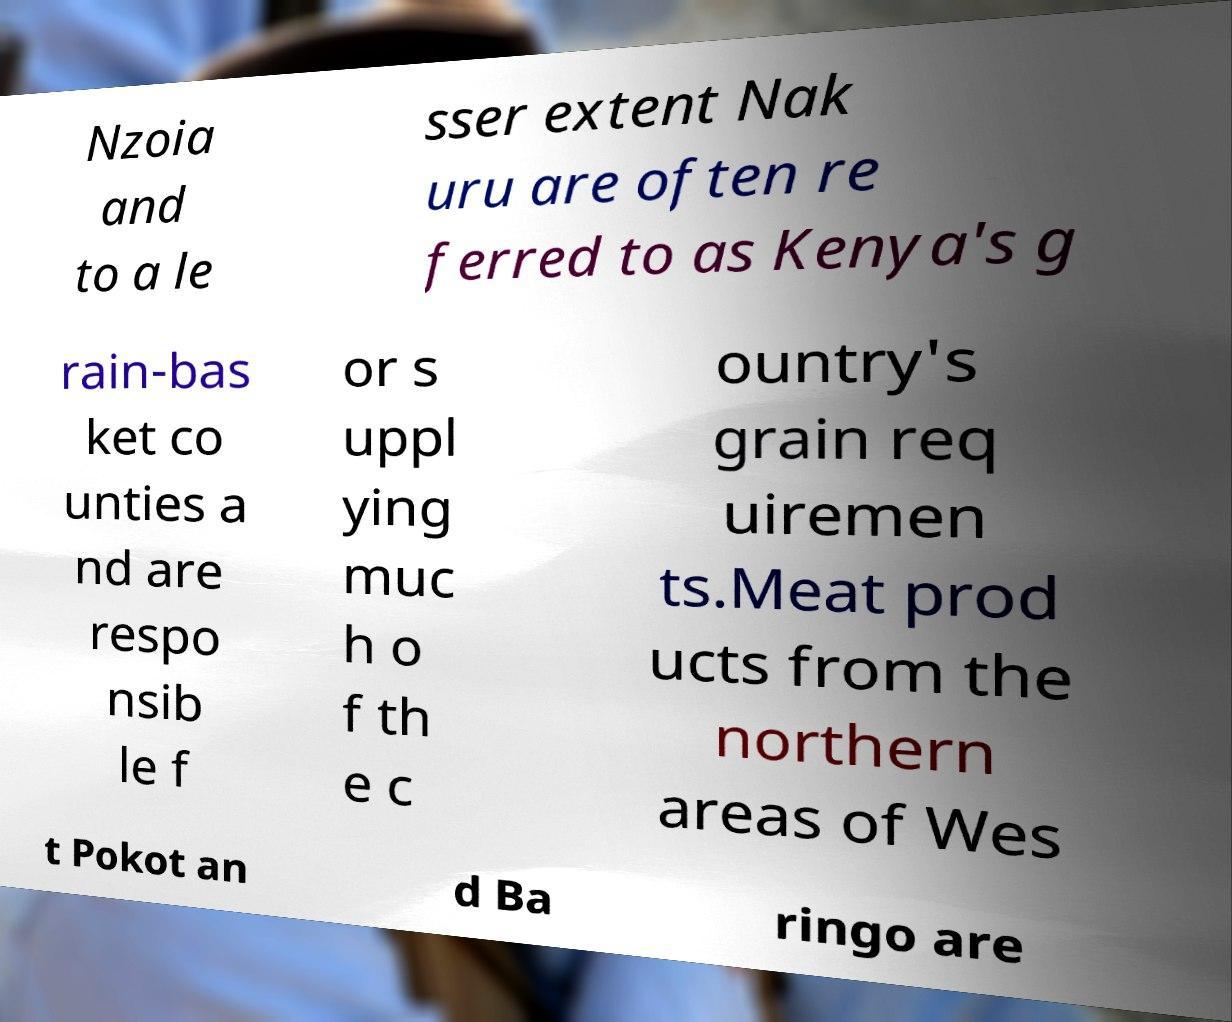Can you accurately transcribe the text from the provided image for me? Nzoia and to a le sser extent Nak uru are often re ferred to as Kenya's g rain-bas ket co unties a nd are respo nsib le f or s uppl ying muc h o f th e c ountry's grain req uiremen ts.Meat prod ucts from the northern areas of Wes t Pokot an d Ba ringo are 